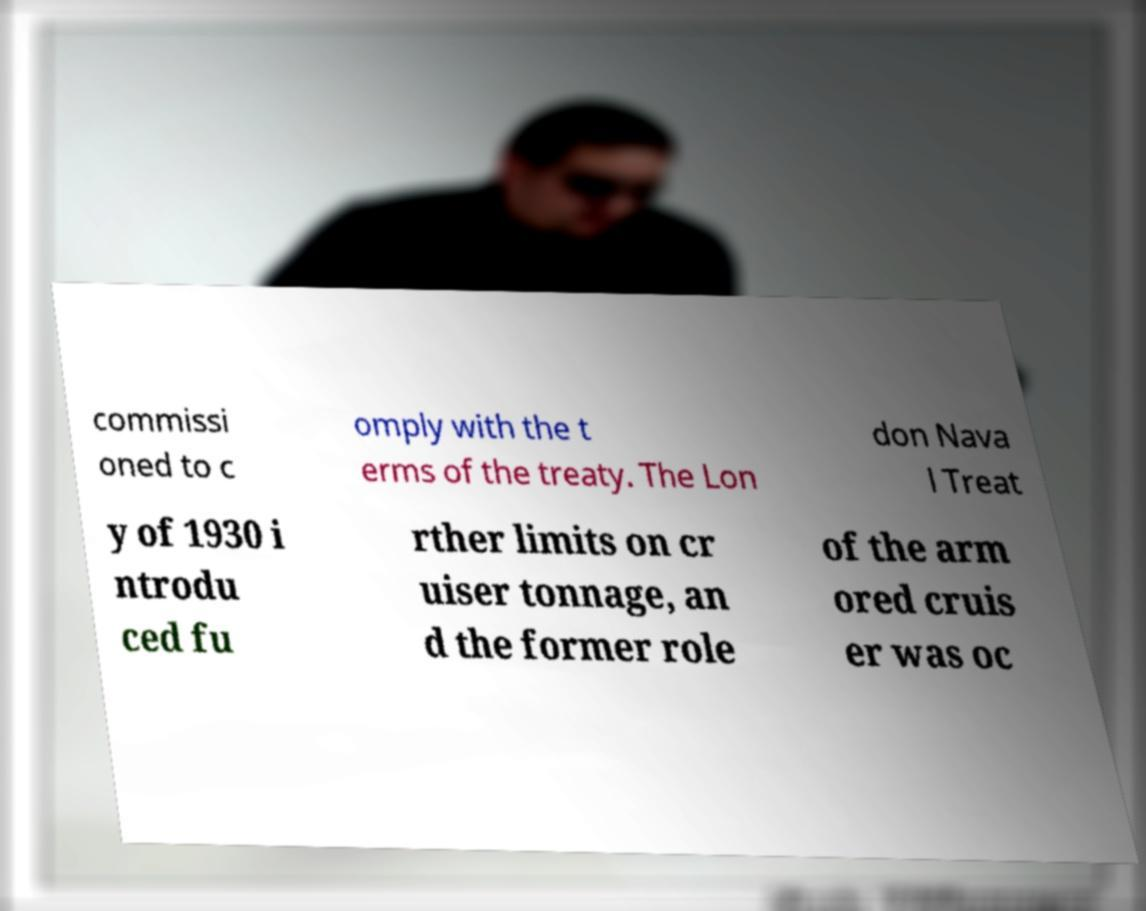What messages or text are displayed in this image? I need them in a readable, typed format. commissi oned to c omply with the t erms of the treaty. The Lon don Nava l Treat y of 1930 i ntrodu ced fu rther limits on cr uiser tonnage, an d the former role of the arm ored cruis er was oc 